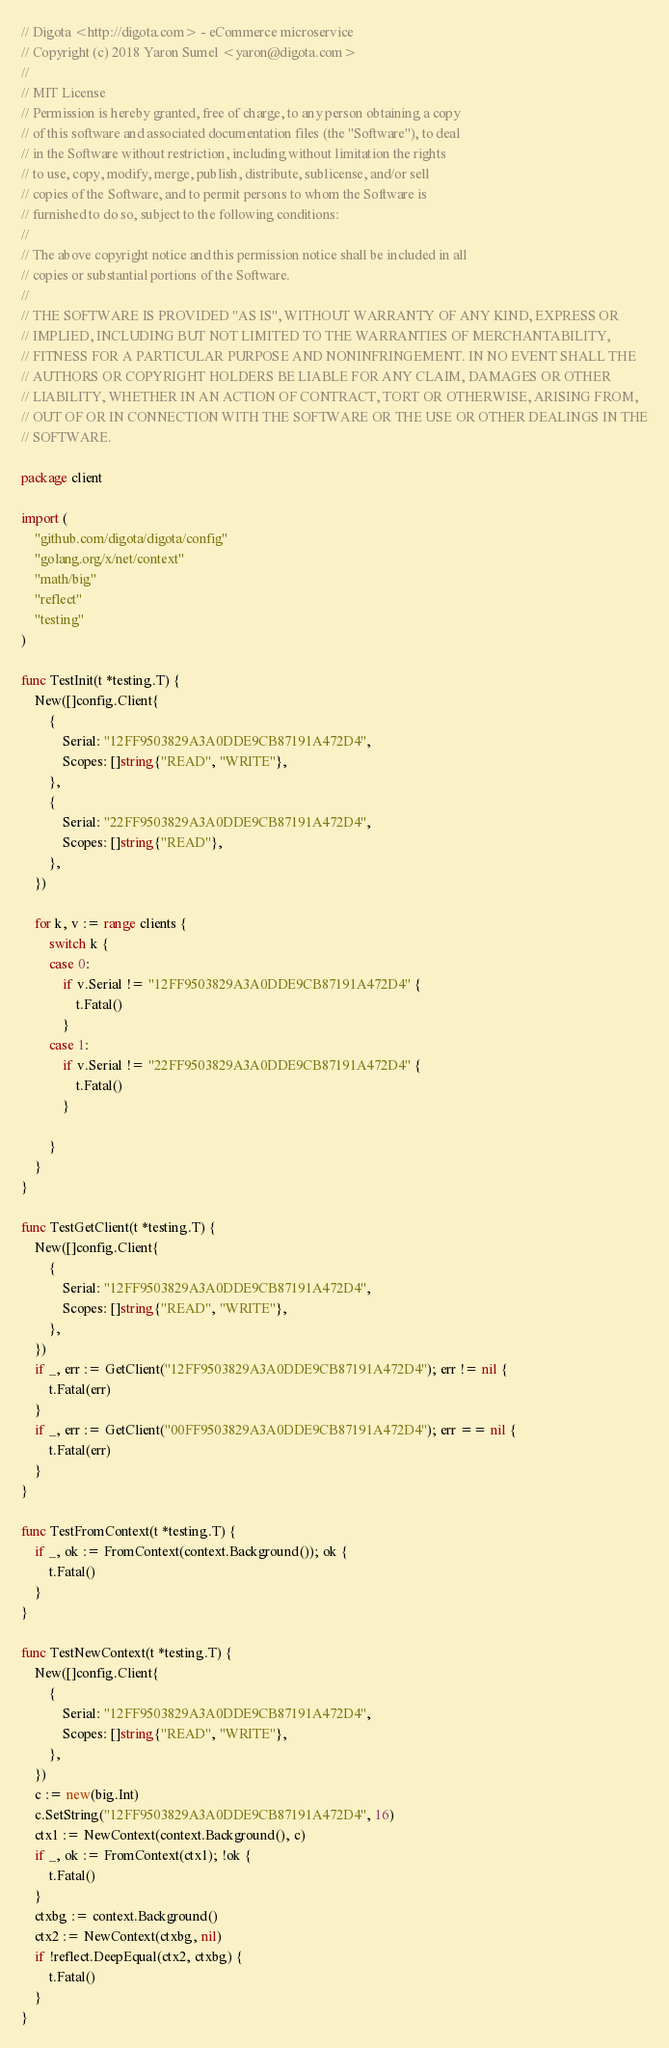<code> <loc_0><loc_0><loc_500><loc_500><_Go_>// Digota <http://digota.com> - eCommerce microservice
// Copyright (c) 2018 Yaron Sumel <yaron@digota.com>
//
// MIT License
// Permission is hereby granted, free of charge, to any person obtaining a copy
// of this software and associated documentation files (the "Software"), to deal
// in the Software without restriction, including without limitation the rights
// to use, copy, modify, merge, publish, distribute, sublicense, and/or sell
// copies of the Software, and to permit persons to whom the Software is
// furnished to do so, subject to the following conditions:
//
// The above copyright notice and this permission notice shall be included in all
// copies or substantial portions of the Software.
//
// THE SOFTWARE IS PROVIDED "AS IS", WITHOUT WARRANTY OF ANY KIND, EXPRESS OR
// IMPLIED, INCLUDING BUT NOT LIMITED TO THE WARRANTIES OF MERCHANTABILITY,
// FITNESS FOR A PARTICULAR PURPOSE AND NONINFRINGEMENT. IN NO EVENT SHALL THE
// AUTHORS OR COPYRIGHT HOLDERS BE LIABLE FOR ANY CLAIM, DAMAGES OR OTHER
// LIABILITY, WHETHER IN AN ACTION OF CONTRACT, TORT OR OTHERWISE, ARISING FROM,
// OUT OF OR IN CONNECTION WITH THE SOFTWARE OR THE USE OR OTHER DEALINGS IN THE
// SOFTWARE.

package client

import (
	"github.com/digota/digota/config"
	"golang.org/x/net/context"
	"math/big"
	"reflect"
	"testing"
)

func TestInit(t *testing.T) {
	New([]config.Client{
		{
			Serial: "12FF9503829A3A0DDE9CB87191A472D4",
			Scopes: []string{"READ", "WRITE"},
		},
		{
			Serial: "22FF9503829A3A0DDE9CB87191A472D4",
			Scopes: []string{"READ"},
		},
	})

	for k, v := range clients {
		switch k {
		case 0:
			if v.Serial != "12FF9503829A3A0DDE9CB87191A472D4" {
				t.Fatal()
			}
		case 1:
			if v.Serial != "22FF9503829A3A0DDE9CB87191A472D4" {
				t.Fatal()
			}

		}
	}
}

func TestGetClient(t *testing.T) {
	New([]config.Client{
		{
			Serial: "12FF9503829A3A0DDE9CB87191A472D4",
			Scopes: []string{"READ", "WRITE"},
		},
	})
	if _, err := GetClient("12FF9503829A3A0DDE9CB87191A472D4"); err != nil {
		t.Fatal(err)
	}
	if _, err := GetClient("00FF9503829A3A0DDE9CB87191A472D4"); err == nil {
		t.Fatal(err)
	}
}

func TestFromContext(t *testing.T) {
	if _, ok := FromContext(context.Background()); ok {
		t.Fatal()
	}
}

func TestNewContext(t *testing.T) {
	New([]config.Client{
		{
			Serial: "12FF9503829A3A0DDE9CB87191A472D4",
			Scopes: []string{"READ", "WRITE"},
		},
	})
	c := new(big.Int)
	c.SetString("12FF9503829A3A0DDE9CB87191A472D4", 16)
	ctx1 := NewContext(context.Background(), c)
	if _, ok := FromContext(ctx1); !ok {
		t.Fatal()
	}
	ctxbg := context.Background()
	ctx2 := NewContext(ctxbg, nil)
	if !reflect.DeepEqual(ctx2, ctxbg) {
		t.Fatal()
	}
}
</code> 